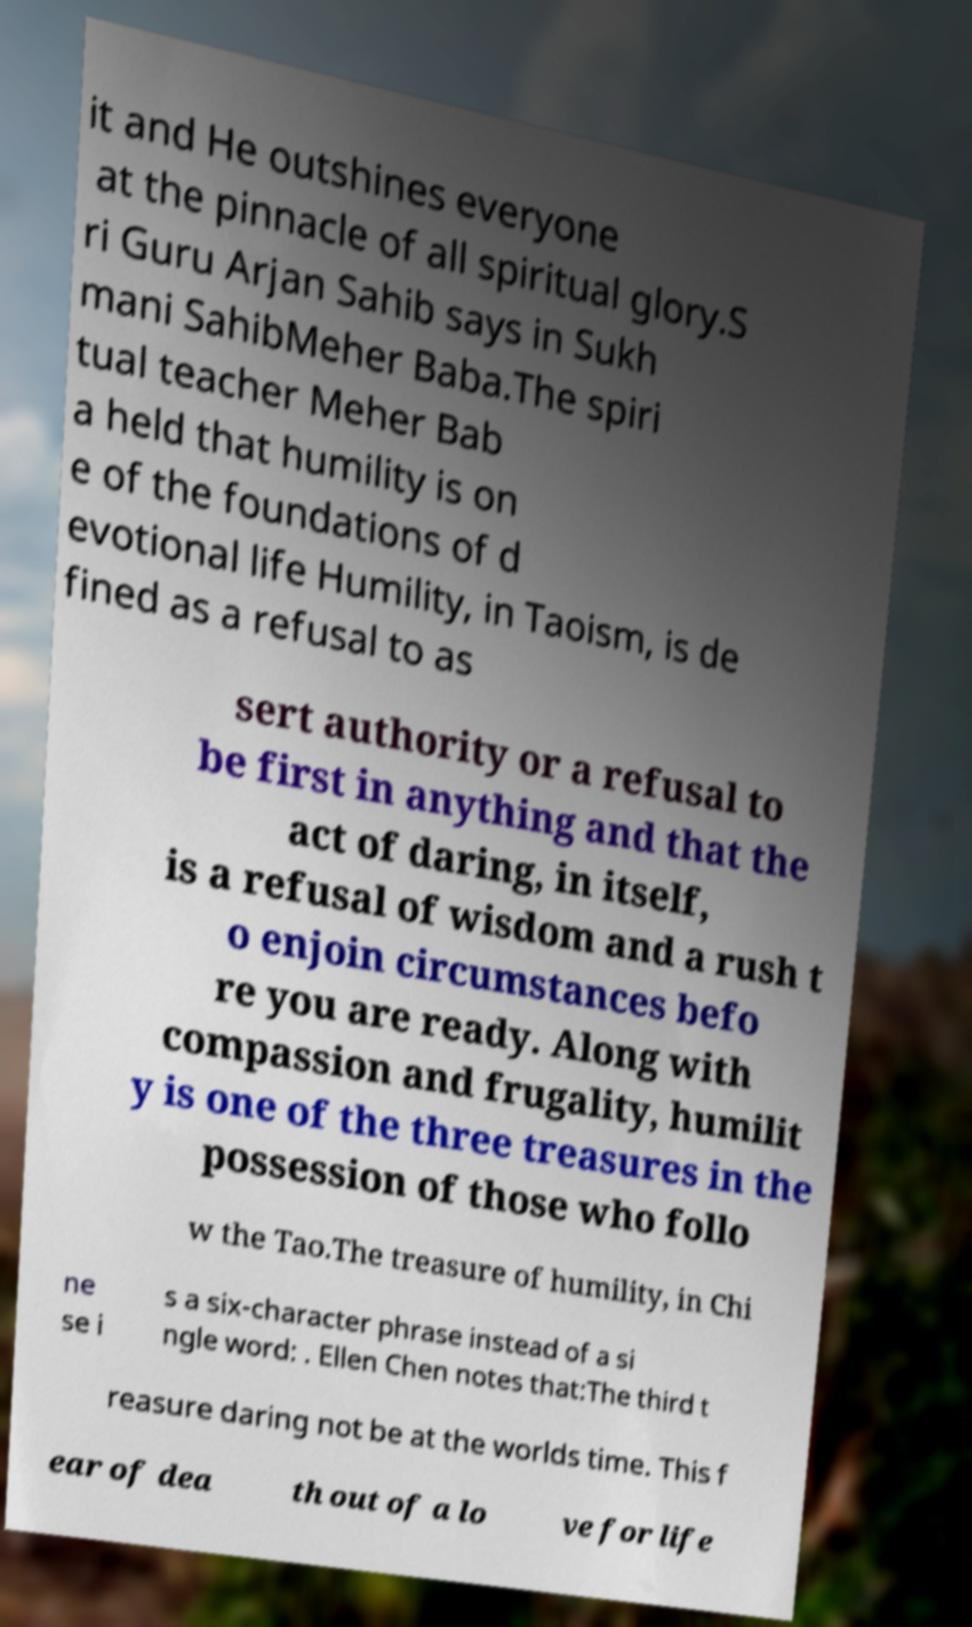What messages or text are displayed in this image? I need them in a readable, typed format. it and He outshines everyone at the pinnacle of all spiritual glory.S ri Guru Arjan Sahib says in Sukh mani SahibMeher Baba.The spiri tual teacher Meher Bab a held that humility is on e of the foundations of d evotional life Humility, in Taoism, is de fined as a refusal to as sert authority or a refusal to be first in anything and that the act of daring, in itself, is a refusal of wisdom and a rush t o enjoin circumstances befo re you are ready. Along with compassion and frugality, humilit y is one of the three treasures in the possession of those who follo w the Tao.The treasure of humility, in Chi ne se i s a six-character phrase instead of a si ngle word: . Ellen Chen notes that:The third t reasure daring not be at the worlds time. This f ear of dea th out of a lo ve for life 